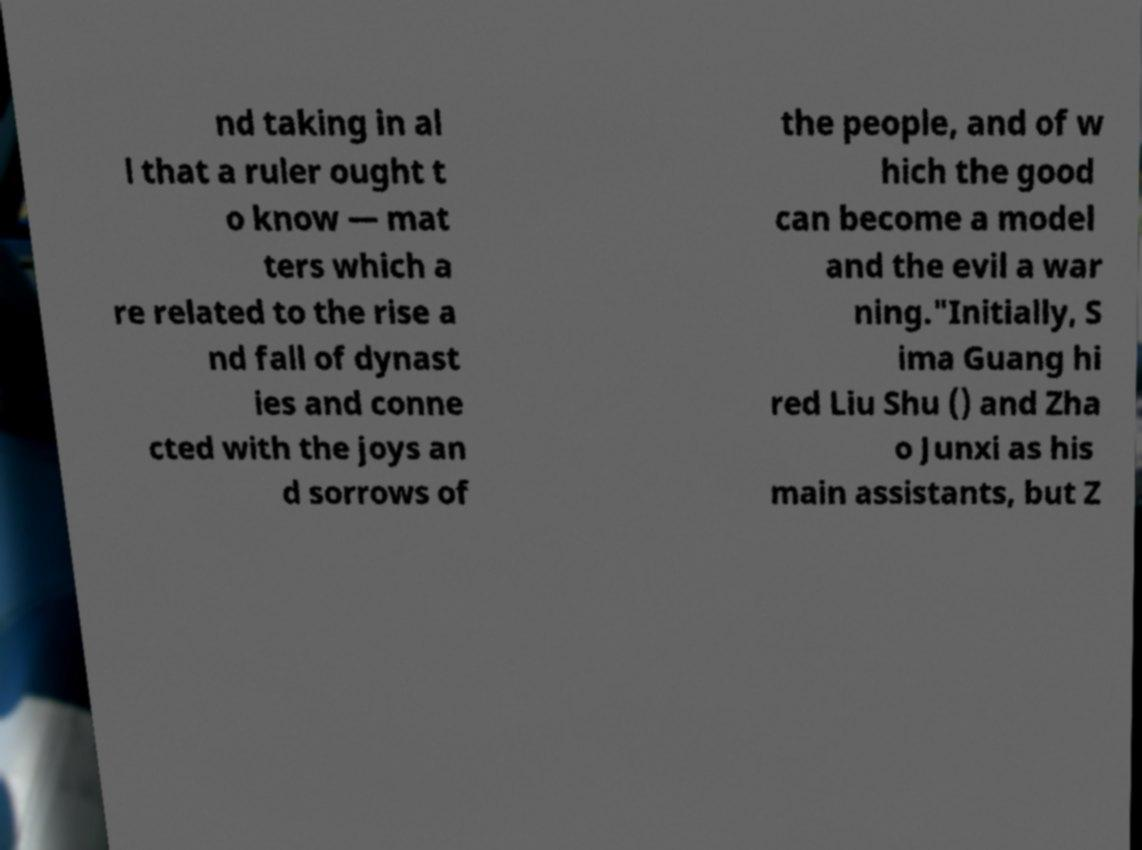For documentation purposes, I need the text within this image transcribed. Could you provide that? nd taking in al l that a ruler ought t o know — mat ters which a re related to the rise a nd fall of dynast ies and conne cted with the joys an d sorrows of the people, and of w hich the good can become a model and the evil a war ning."Initially, S ima Guang hi red Liu Shu () and Zha o Junxi as his main assistants, but Z 